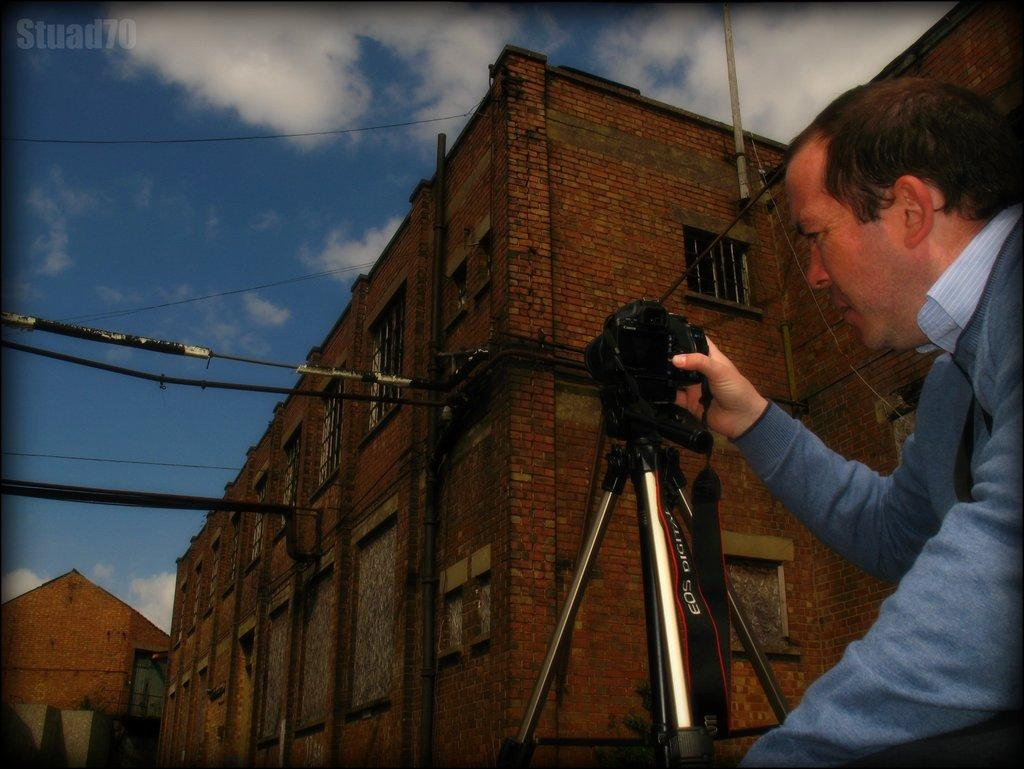What can be seen in the background of the image? There is a sky in the image, and it contains clouds. What type of structure is present in the image? There is a building in the image. Who is in the image, and what is he doing? There is a man in the image, and he is holding a camera. What color is the man's hair in the image? The provided facts do not mention the man's hair color, so we cannot determine it from the image. What is the man using to cover his arm in the image? There is no indication in the image that the man is using anything to cover his arm. 